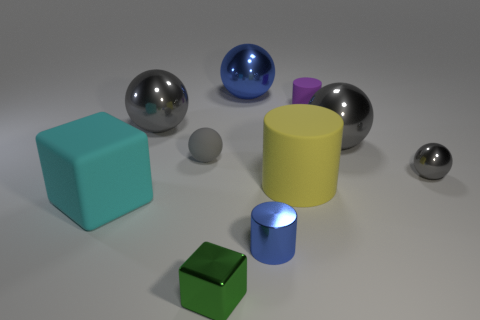Is the tiny shiny ball the same color as the rubber sphere?
Your answer should be very brief. Yes. There is a small thing that is the same color as the tiny shiny sphere; what is it made of?
Provide a short and direct response. Rubber. Is the big cyan matte thing the same shape as the big yellow object?
Make the answer very short. No. Is there any other thing of the same color as the tiny shiny cylinder?
Your response must be concise. Yes. The other metallic object that is the same shape as the large cyan object is what color?
Offer a very short reply. Green. Are there more large gray things that are right of the blue metal ball than small gray shiny balls?
Give a very brief answer. No. What color is the big ball that is to the left of the green metallic object?
Offer a very short reply. Gray. Do the metal cylinder and the yellow thing have the same size?
Keep it short and to the point. No. The green metallic block is what size?
Provide a short and direct response. Small. What is the shape of the tiny shiny object that is the same color as the tiny matte ball?
Offer a terse response. Sphere. 